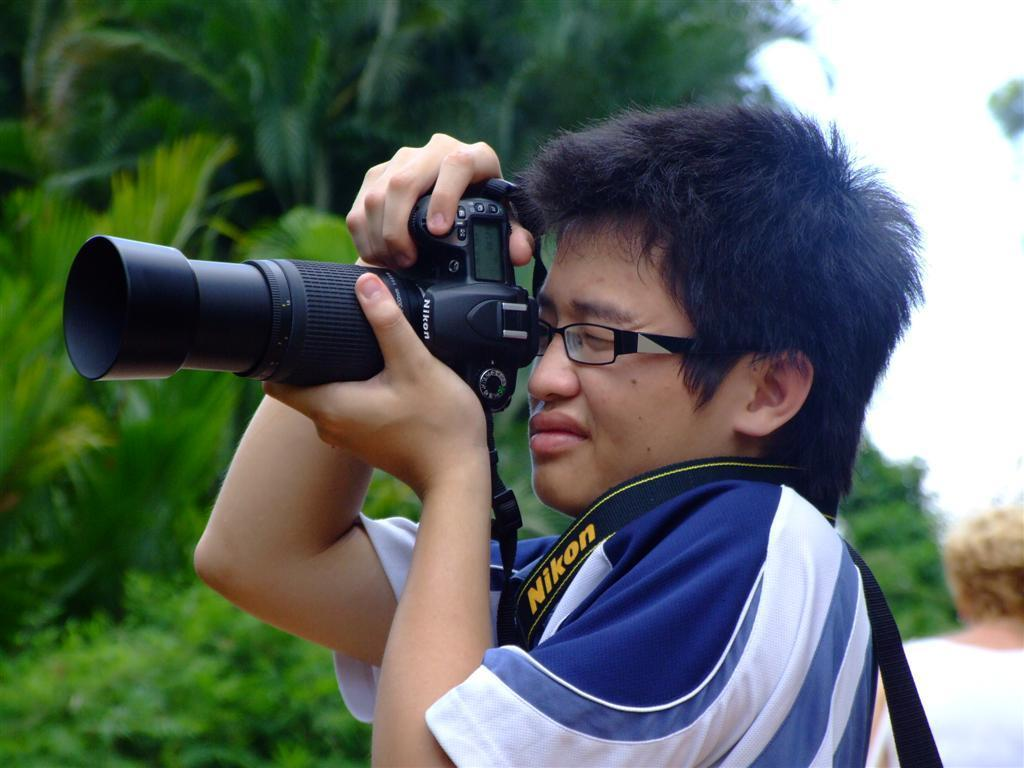What is the person in the image wearing? The person is wearing a blue and white color dress in the image. Can you describe any accessories the person is wearing? The person is wearing specs in the image. What is the person holding in the image? The person is holding a camera in the image. What can be seen in the background of the image? There are many trees and the sky visible in the background of the image. What religion does the person in the image represent? There is no information about the person's religion in the image, so it cannot be determined. 